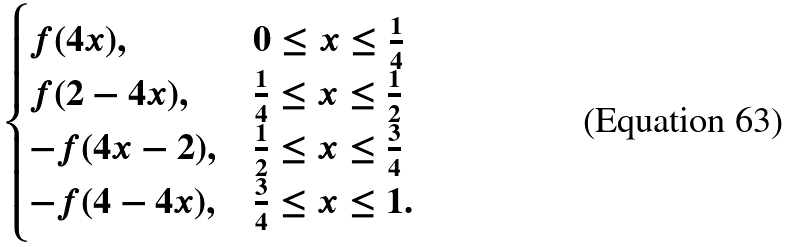<formula> <loc_0><loc_0><loc_500><loc_500>\begin{cases} f ( 4 x ) , & 0 \leq x \leq \frac { 1 } { 4 } \\ f ( 2 - 4 x ) , & \frac { 1 } { 4 } \leq x \leq \frac { 1 } { 2 } \\ - f ( 4 x - 2 ) , & \frac { 1 } { 2 } \leq x \leq \frac { 3 } { 4 } \\ - f ( 4 - 4 x ) , & \frac { 3 } { 4 } \leq x \leq 1 . \end{cases}</formula> 